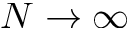Convert formula to latex. <formula><loc_0><loc_0><loc_500><loc_500>N \rightarrow \infty</formula> 